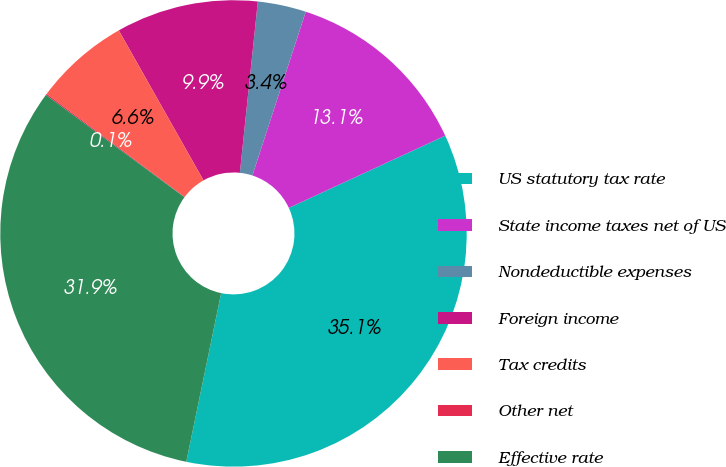Convert chart. <chart><loc_0><loc_0><loc_500><loc_500><pie_chart><fcel>US statutory tax rate<fcel>State income taxes net of US<fcel>Nondeductible expenses<fcel>Foreign income<fcel>Tax credits<fcel>Other net<fcel>Effective rate<nl><fcel>35.13%<fcel>13.1%<fcel>3.35%<fcel>9.85%<fcel>6.6%<fcel>0.09%<fcel>31.88%<nl></chart> 